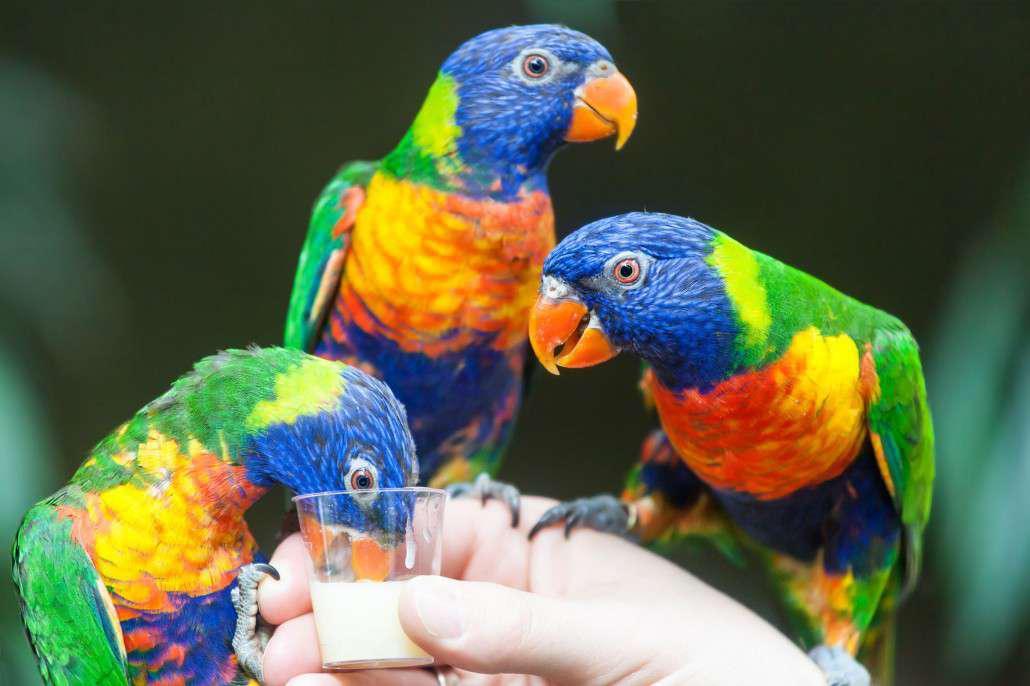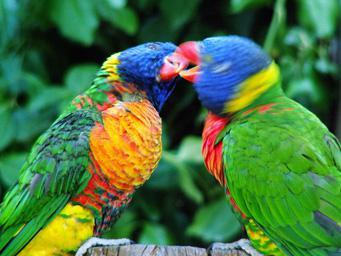The first image is the image on the left, the second image is the image on the right. Considering the images on both sides, is "One bird stands alone." valid? Answer yes or no. No. The first image is the image on the left, the second image is the image on the right. Assess this claim about the two images: "One image contains an entire flock of birds, 5 or more.". Correct or not? Answer yes or no. No. 